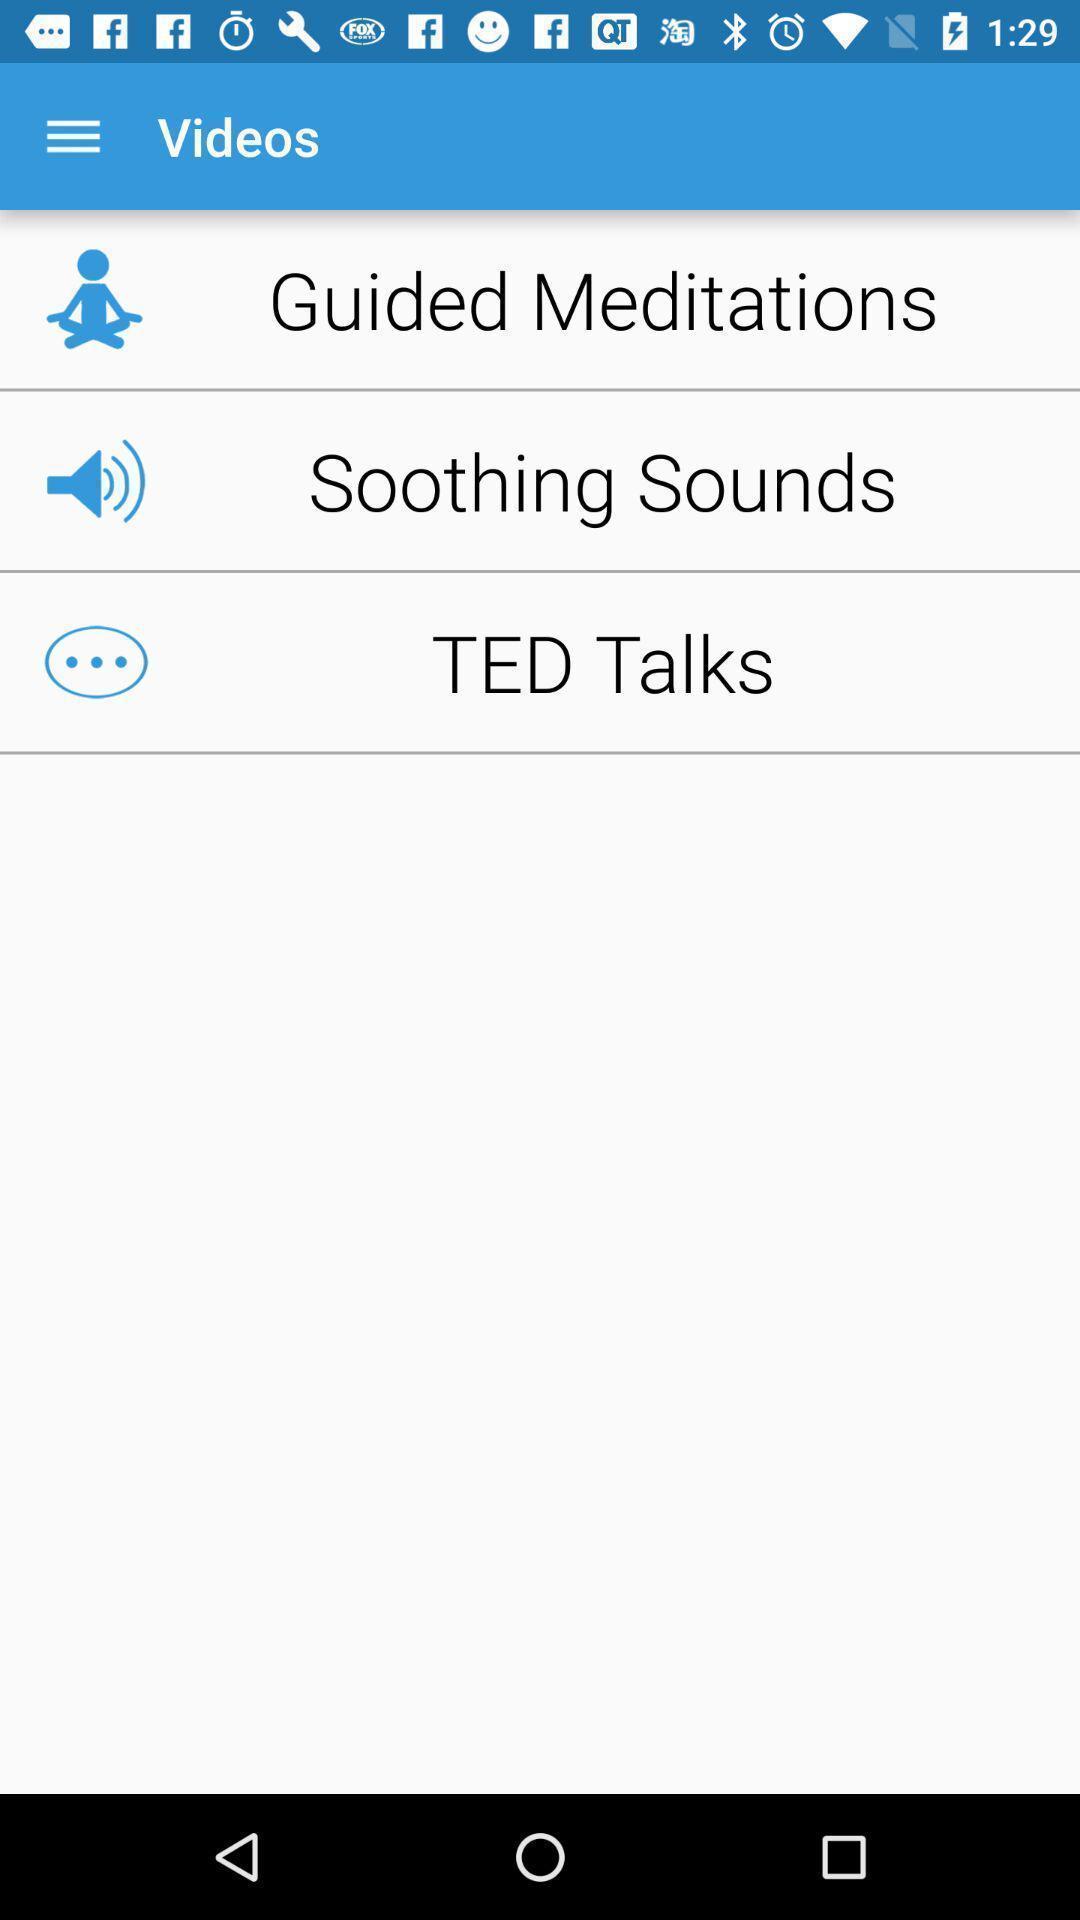Provide a textual representation of this image. Page shows the various videos on motivational app. 